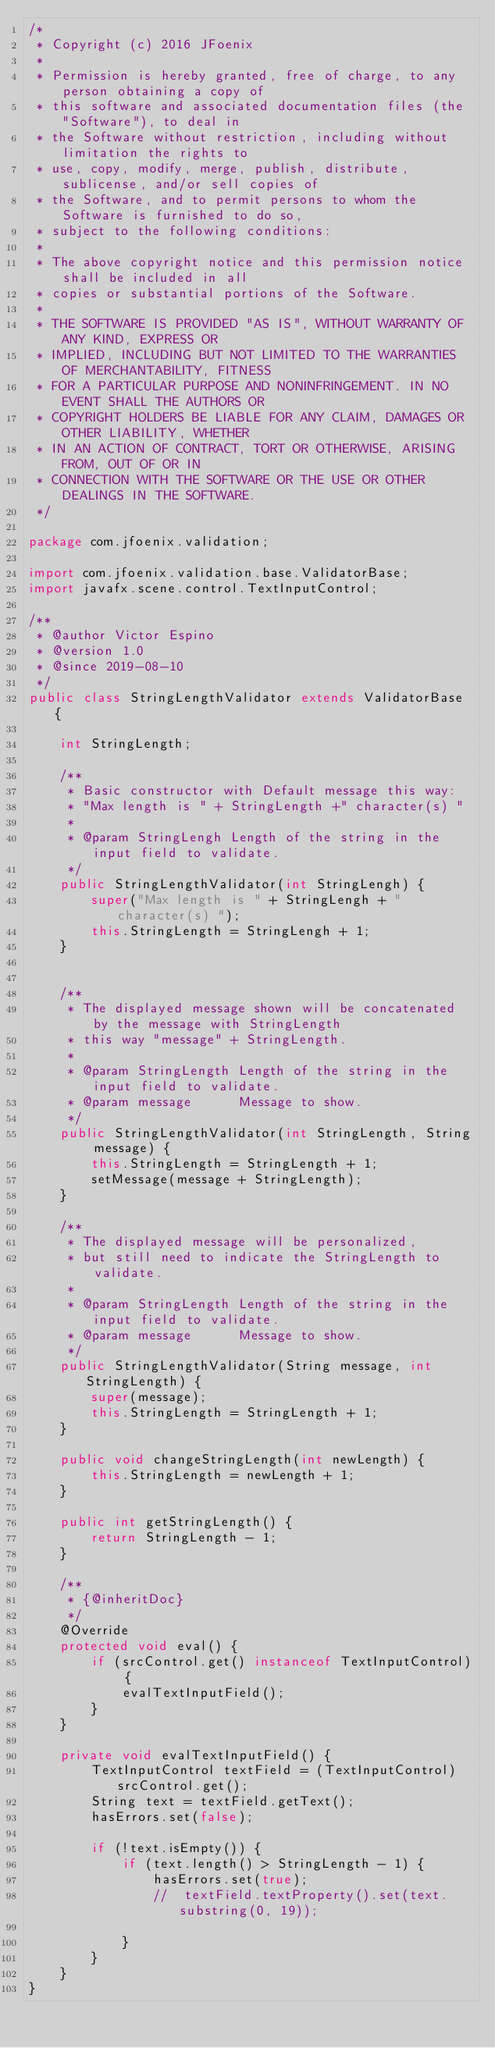Convert code to text. <code><loc_0><loc_0><loc_500><loc_500><_Java_>/*
 * Copyright (c) 2016 JFoenix
 *
 * Permission is hereby granted, free of charge, to any person obtaining a copy of
 * this software and associated documentation files (the "Software"), to deal in
 * the Software without restriction, including without limitation the rights to
 * use, copy, modify, merge, publish, distribute, sublicense, and/or sell copies of
 * the Software, and to permit persons to whom the Software is furnished to do so,
 * subject to the following conditions:
 *
 * The above copyright notice and this permission notice shall be included in all
 * copies or substantial portions of the Software.
 *
 * THE SOFTWARE IS PROVIDED "AS IS", WITHOUT WARRANTY OF ANY KIND, EXPRESS OR
 * IMPLIED, INCLUDING BUT NOT LIMITED TO THE WARRANTIES OF MERCHANTABILITY, FITNESS
 * FOR A PARTICULAR PURPOSE AND NONINFRINGEMENT. IN NO EVENT SHALL THE AUTHORS OR
 * COPYRIGHT HOLDERS BE LIABLE FOR ANY CLAIM, DAMAGES OR OTHER LIABILITY, WHETHER
 * IN AN ACTION OF CONTRACT, TORT OR OTHERWISE, ARISING FROM, OUT OF OR IN
 * CONNECTION WITH THE SOFTWARE OR THE USE OR OTHER DEALINGS IN THE SOFTWARE.
 */

package com.jfoenix.validation;

import com.jfoenix.validation.base.ValidatorBase;
import javafx.scene.control.TextInputControl;

/**
 * @author Victor Espino
 * @version 1.0
 * @since 2019-08-10
 */
public class StringLengthValidator extends ValidatorBase {

    int StringLength;

    /**
     * Basic constructor with Default message this way:
     * "Max length is " + StringLength +" character(s) "
     *
     * @param StringLengh Length of the string in the input field to validate.
     */
    public StringLengthValidator(int StringLengh) {
        super("Max length is " + StringLengh + " character(s) ");
        this.StringLength = StringLengh + 1;
    }


    /**
     * The displayed message shown will be concatenated by the message with StringLength
     * this way "message" + StringLength.
     *
     * @param StringLength Length of the string in the input field to validate.
     * @param message      Message to show.
     */
    public StringLengthValidator(int StringLength, String message) {
        this.StringLength = StringLength + 1;
        setMessage(message + StringLength);
    }

    /**
     * The displayed message will be personalized,
     * but still need to indicate the StringLength to validate.
     *
     * @param StringLength Length of the string in the input field to validate.
     * @param message      Message to show.
     */
    public StringLengthValidator(String message, int StringLength) {
        super(message);
        this.StringLength = StringLength + 1;
    }

    public void changeStringLength(int newLength) {
        this.StringLength = newLength + 1;
    }

    public int getStringLength() {
        return StringLength - 1;
    }

    /**
     * {@inheritDoc}
     */
    @Override
    protected void eval() {
        if (srcControl.get() instanceof TextInputControl) {
            evalTextInputField();
        }
    }

    private void evalTextInputField() {
        TextInputControl textField = (TextInputControl) srcControl.get();
        String text = textField.getText();
        hasErrors.set(false);

        if (!text.isEmpty()) {
            if (text.length() > StringLength - 1) {
                hasErrors.set(true);
                //  textField.textProperty().set(text.substring(0, 19));

            }
        }
    }
}
</code> 